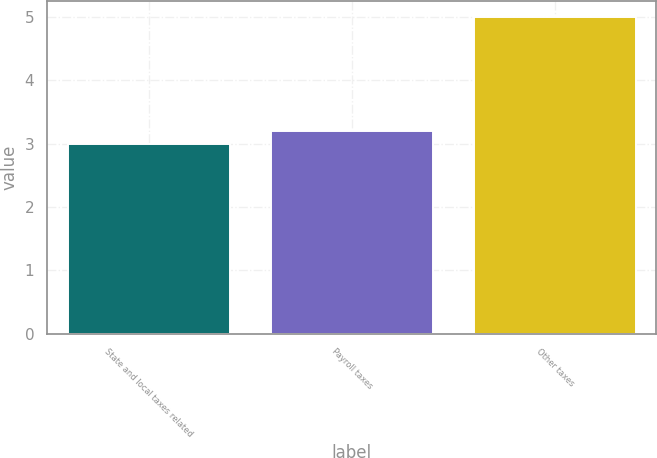<chart> <loc_0><loc_0><loc_500><loc_500><bar_chart><fcel>State and local taxes related<fcel>Payroll taxes<fcel>Other taxes<nl><fcel>3<fcel>3.2<fcel>5<nl></chart> 